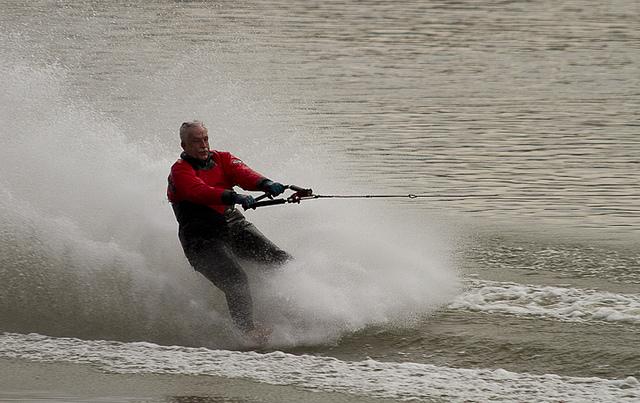Why is the water spraying everywhere?
Concise answer only. Water skiing. What is this man doing?
Quick response, please. Water skiing. What is the man holding onto?
Keep it brief. Handle. 